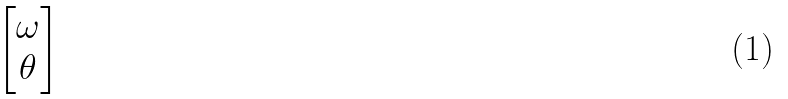<formula> <loc_0><loc_0><loc_500><loc_500>\begin{bmatrix} \omega \\ \theta \end{bmatrix}</formula> 